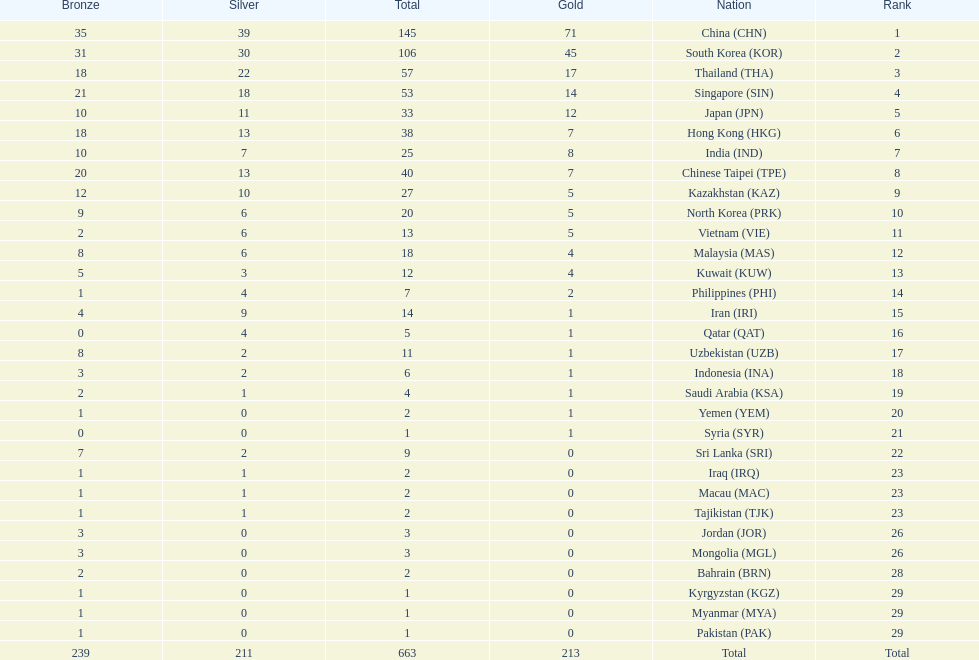What is the difference between the total amount of medals won by qatar and indonesia? 1. 